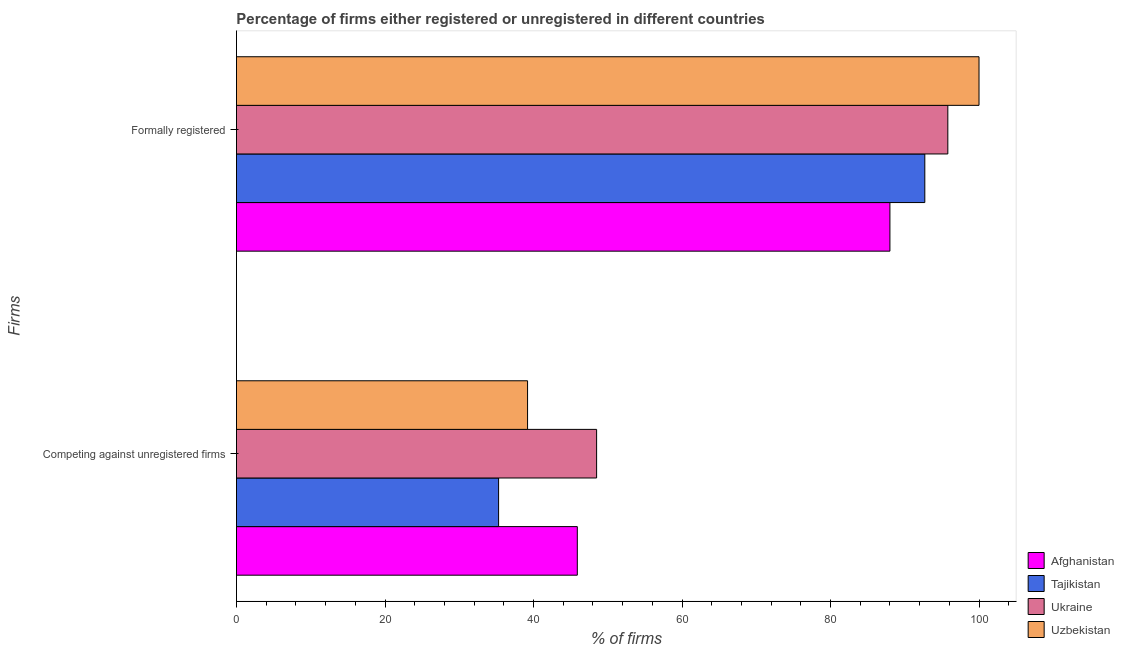How many groups of bars are there?
Keep it short and to the point. 2. Are the number of bars per tick equal to the number of legend labels?
Your answer should be very brief. Yes. Are the number of bars on each tick of the Y-axis equal?
Make the answer very short. Yes. How many bars are there on the 2nd tick from the top?
Offer a terse response. 4. How many bars are there on the 1st tick from the bottom?
Your answer should be compact. 4. What is the label of the 1st group of bars from the top?
Ensure brevity in your answer.  Formally registered. What is the percentage of registered firms in Uzbekistan?
Give a very brief answer. 39.2. Across all countries, what is the maximum percentage of registered firms?
Ensure brevity in your answer.  48.5. Across all countries, what is the minimum percentage of registered firms?
Offer a very short reply. 35.3. In which country was the percentage of formally registered firms maximum?
Your answer should be compact. Uzbekistan. In which country was the percentage of registered firms minimum?
Keep it short and to the point. Tajikistan. What is the total percentage of registered firms in the graph?
Your answer should be very brief. 168.9. What is the difference between the percentage of formally registered firms in Ukraine and that in Tajikistan?
Keep it short and to the point. 3.1. What is the difference between the percentage of registered firms in Ukraine and the percentage of formally registered firms in Afghanistan?
Offer a terse response. -39.5. What is the average percentage of formally registered firms per country?
Make the answer very short. 94.12. What is the difference between the percentage of formally registered firms and percentage of registered firms in Uzbekistan?
Ensure brevity in your answer.  60.8. What is the ratio of the percentage of formally registered firms in Afghanistan to that in Ukraine?
Give a very brief answer. 0.92. Is the percentage of registered firms in Ukraine less than that in Afghanistan?
Offer a very short reply. No. In how many countries, is the percentage of formally registered firms greater than the average percentage of formally registered firms taken over all countries?
Provide a succinct answer. 2. What does the 2nd bar from the top in Formally registered represents?
Provide a succinct answer. Ukraine. What does the 4th bar from the bottom in Competing against unregistered firms represents?
Make the answer very short. Uzbekistan. How many bars are there?
Ensure brevity in your answer.  8. Are all the bars in the graph horizontal?
Offer a very short reply. Yes. How many countries are there in the graph?
Your answer should be very brief. 4. What is the difference between two consecutive major ticks on the X-axis?
Offer a terse response. 20. Are the values on the major ticks of X-axis written in scientific E-notation?
Provide a succinct answer. No. Where does the legend appear in the graph?
Your answer should be very brief. Bottom right. How many legend labels are there?
Keep it short and to the point. 4. How are the legend labels stacked?
Your answer should be compact. Vertical. What is the title of the graph?
Your answer should be very brief. Percentage of firms either registered or unregistered in different countries. What is the label or title of the X-axis?
Keep it short and to the point. % of firms. What is the label or title of the Y-axis?
Make the answer very short. Firms. What is the % of firms in Afghanistan in Competing against unregistered firms?
Offer a very short reply. 45.9. What is the % of firms of Tajikistan in Competing against unregistered firms?
Make the answer very short. 35.3. What is the % of firms of Ukraine in Competing against unregistered firms?
Provide a short and direct response. 48.5. What is the % of firms in Uzbekistan in Competing against unregistered firms?
Provide a succinct answer. 39.2. What is the % of firms in Afghanistan in Formally registered?
Offer a very short reply. 88. What is the % of firms of Tajikistan in Formally registered?
Ensure brevity in your answer.  92.7. What is the % of firms in Ukraine in Formally registered?
Your response must be concise. 95.8. Across all Firms, what is the maximum % of firms in Tajikistan?
Provide a short and direct response. 92.7. Across all Firms, what is the maximum % of firms in Ukraine?
Provide a short and direct response. 95.8. Across all Firms, what is the minimum % of firms of Afghanistan?
Your answer should be very brief. 45.9. Across all Firms, what is the minimum % of firms in Tajikistan?
Provide a short and direct response. 35.3. Across all Firms, what is the minimum % of firms in Ukraine?
Provide a short and direct response. 48.5. Across all Firms, what is the minimum % of firms in Uzbekistan?
Your answer should be compact. 39.2. What is the total % of firms of Afghanistan in the graph?
Give a very brief answer. 133.9. What is the total % of firms in Tajikistan in the graph?
Keep it short and to the point. 128. What is the total % of firms in Ukraine in the graph?
Ensure brevity in your answer.  144.3. What is the total % of firms of Uzbekistan in the graph?
Provide a short and direct response. 139.2. What is the difference between the % of firms of Afghanistan in Competing against unregistered firms and that in Formally registered?
Offer a terse response. -42.1. What is the difference between the % of firms in Tajikistan in Competing against unregistered firms and that in Formally registered?
Your answer should be compact. -57.4. What is the difference between the % of firms in Ukraine in Competing against unregistered firms and that in Formally registered?
Make the answer very short. -47.3. What is the difference between the % of firms in Uzbekistan in Competing against unregistered firms and that in Formally registered?
Keep it short and to the point. -60.8. What is the difference between the % of firms in Afghanistan in Competing against unregistered firms and the % of firms in Tajikistan in Formally registered?
Keep it short and to the point. -46.8. What is the difference between the % of firms of Afghanistan in Competing against unregistered firms and the % of firms of Ukraine in Formally registered?
Offer a terse response. -49.9. What is the difference between the % of firms of Afghanistan in Competing against unregistered firms and the % of firms of Uzbekistan in Formally registered?
Make the answer very short. -54.1. What is the difference between the % of firms in Tajikistan in Competing against unregistered firms and the % of firms in Ukraine in Formally registered?
Ensure brevity in your answer.  -60.5. What is the difference between the % of firms in Tajikistan in Competing against unregistered firms and the % of firms in Uzbekistan in Formally registered?
Your response must be concise. -64.7. What is the difference between the % of firms in Ukraine in Competing against unregistered firms and the % of firms in Uzbekistan in Formally registered?
Provide a short and direct response. -51.5. What is the average % of firms of Afghanistan per Firms?
Give a very brief answer. 66.95. What is the average % of firms of Ukraine per Firms?
Ensure brevity in your answer.  72.15. What is the average % of firms of Uzbekistan per Firms?
Provide a short and direct response. 69.6. What is the difference between the % of firms in Afghanistan and % of firms in Uzbekistan in Competing against unregistered firms?
Offer a very short reply. 6.7. What is the difference between the % of firms in Afghanistan and % of firms in Tajikistan in Formally registered?
Provide a short and direct response. -4.7. What is the difference between the % of firms of Afghanistan and % of firms of Uzbekistan in Formally registered?
Your answer should be very brief. -12. What is the difference between the % of firms of Tajikistan and % of firms of Ukraine in Formally registered?
Provide a short and direct response. -3.1. What is the ratio of the % of firms of Afghanistan in Competing against unregistered firms to that in Formally registered?
Your answer should be compact. 0.52. What is the ratio of the % of firms of Tajikistan in Competing against unregistered firms to that in Formally registered?
Offer a terse response. 0.38. What is the ratio of the % of firms of Ukraine in Competing against unregistered firms to that in Formally registered?
Give a very brief answer. 0.51. What is the ratio of the % of firms of Uzbekistan in Competing against unregistered firms to that in Formally registered?
Ensure brevity in your answer.  0.39. What is the difference between the highest and the second highest % of firms of Afghanistan?
Your answer should be compact. 42.1. What is the difference between the highest and the second highest % of firms of Tajikistan?
Your response must be concise. 57.4. What is the difference between the highest and the second highest % of firms in Ukraine?
Make the answer very short. 47.3. What is the difference between the highest and the second highest % of firms of Uzbekistan?
Your answer should be compact. 60.8. What is the difference between the highest and the lowest % of firms in Afghanistan?
Provide a succinct answer. 42.1. What is the difference between the highest and the lowest % of firms in Tajikistan?
Your answer should be compact. 57.4. What is the difference between the highest and the lowest % of firms of Ukraine?
Ensure brevity in your answer.  47.3. What is the difference between the highest and the lowest % of firms in Uzbekistan?
Keep it short and to the point. 60.8. 